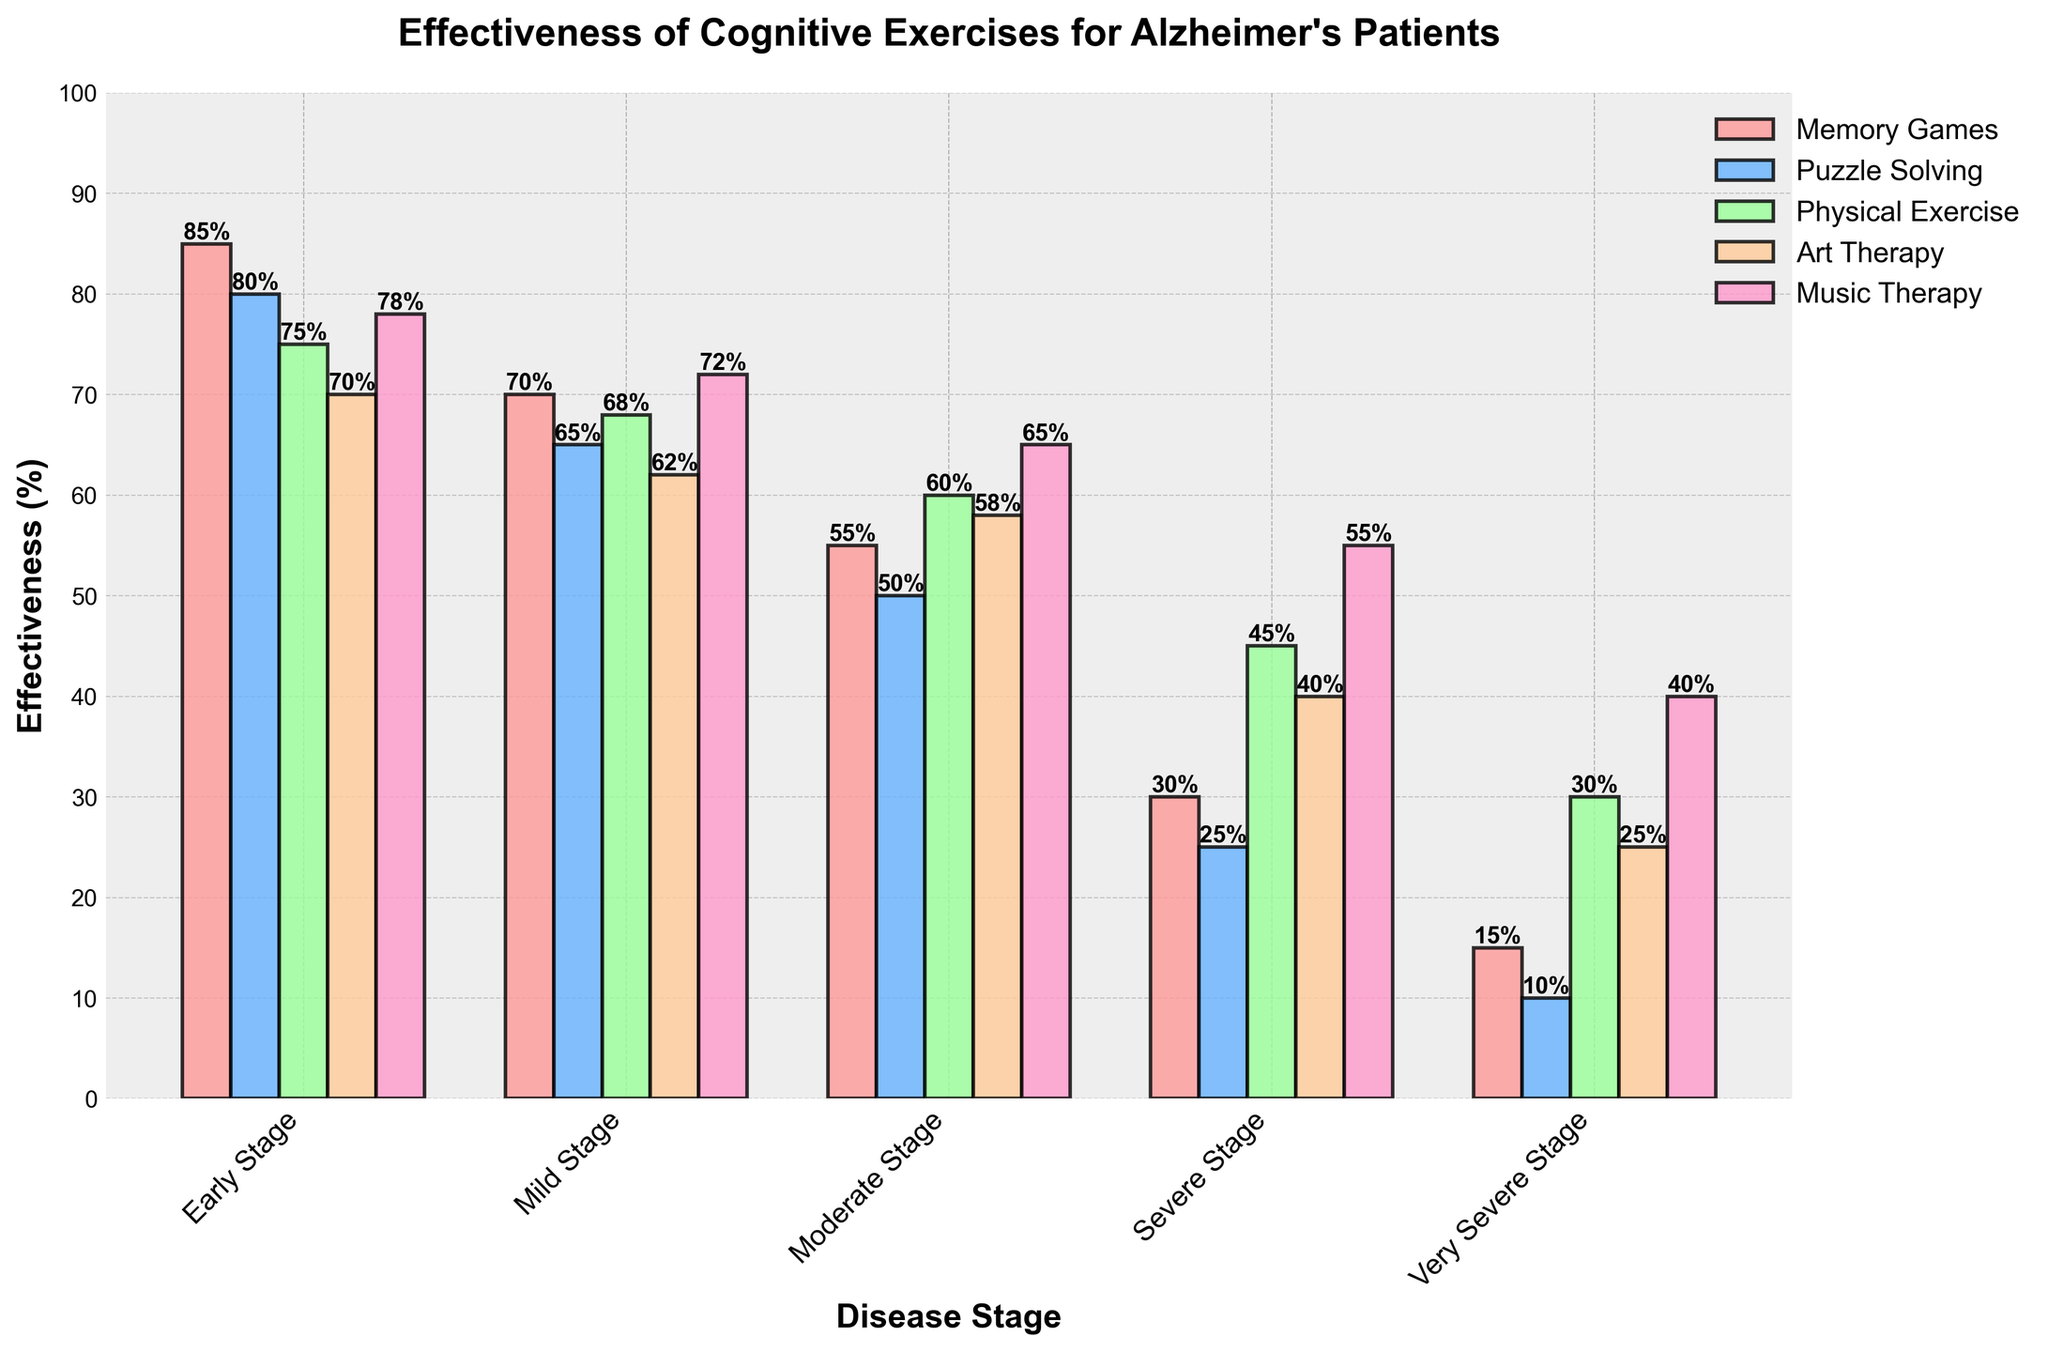Which cognitive exercise is most effective in the early stage? Observing the heights of the bars in the "Early Stage" category, Memory Games has the highest bar among other cognitive exercises.
Answer: Memory Games What is the difference in effectiveness between Memory Games and Puzzle Solving in the moderate stage? From the "Moderate Stage" category, Memory Games has a value of 55 and Puzzle Solving has 50. The difference is calculated as 55 - 50 = 5.
Answer: 5 Which two types of exercise have the closest effectiveness in the severe stage? Looking at the "Severe Stage" category and comparing the heights of the bars, Puzzle Solving (25%) and Art Therapy (40%) are closest. The difference between them is 40 - 25 = 15, which is smaller than any other pair.
Answer: Puzzle Solving and Art Therapy What is the average effectiveness of Music Therapy across all stages? Music Therapy effectiveness values are [78, 72, 65, 55, 40]. Summing them up gives 78 + 72 + 65 + 55 + 40 = 310. Dividing by 5 stages, we get 310 / 5 = 62.
Answer: 62 Which stage shows the least difference between the highest and lowest effectiveness? Observing the difference between the highest and lowest values in each stage: Early (85 - 70 = 15), Mild (70 - 62 = 8), Moderate (60 - 50 = 10), Severe (55 - 25 = 30), and Very Severe (40 - 10 = 30). Mild stage has the smallest difference, which is 8.
Answer: Mild Stage How much more effective is Physical Exercise than Puzzle Solving in the very severe stage? From the "Very Severe Stage" category, Physical Exercise has 30% and Puzzle Solving has 10%. The difference is 30 - 10 = 20.
Answer: 20 What is the combined effectiveness of Art Therapy and Music Therapy in the mild stage? In the "Mild Stage" category, Art Therapy has a value of 62 and Music Therapy has 72. Summing them gives 62 + 72 = 134.
Answer: 134 Which exercise shows the most consistent effectiveness across all stages? Examining the height changes of the bars for each exercise: Puzzle Solving (80-65-50-25-10 is more consistent compared to others), which shows the least fluctuation.
Answer: Puzzle Solving 